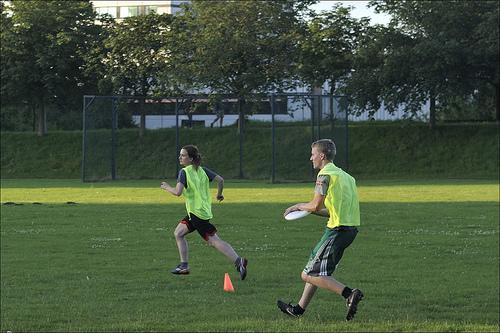Question: what are the people doing?
Choices:
A. Baseball.
B. Basketball.
C. Football.
D. Playing frisbee.
Answer with the letter. Answer: D Question: why is there a orange cone?
Choices:
A. Boundaries.
B. Traffic lines.
C. To regulate lanes.
D. To warn drivers.
Answer with the letter. Answer: A Question: who is holding the Frisbee?
Choices:
A. Boy on left.
B. Girl on right.
C. Boy on right.
D. Girl on left.
Answer with the letter. Answer: C Question: where is the bench?
Choices:
A. On the right.
B. There is no bench.
C. On the left.
D. In front.
Answer with the letter. Answer: B Question: what color are the leaves?
Choices:
A. Brown.
B. Green.
C. Light brown.
D. Dark green.
Answer with the letter. Answer: B 